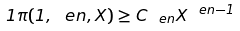<formula> <loc_0><loc_0><loc_500><loc_500>1 \pi ( 1 , \ e n , X ) \geq C _ { \ e n } X ^ { \ e n - 1 }</formula> 